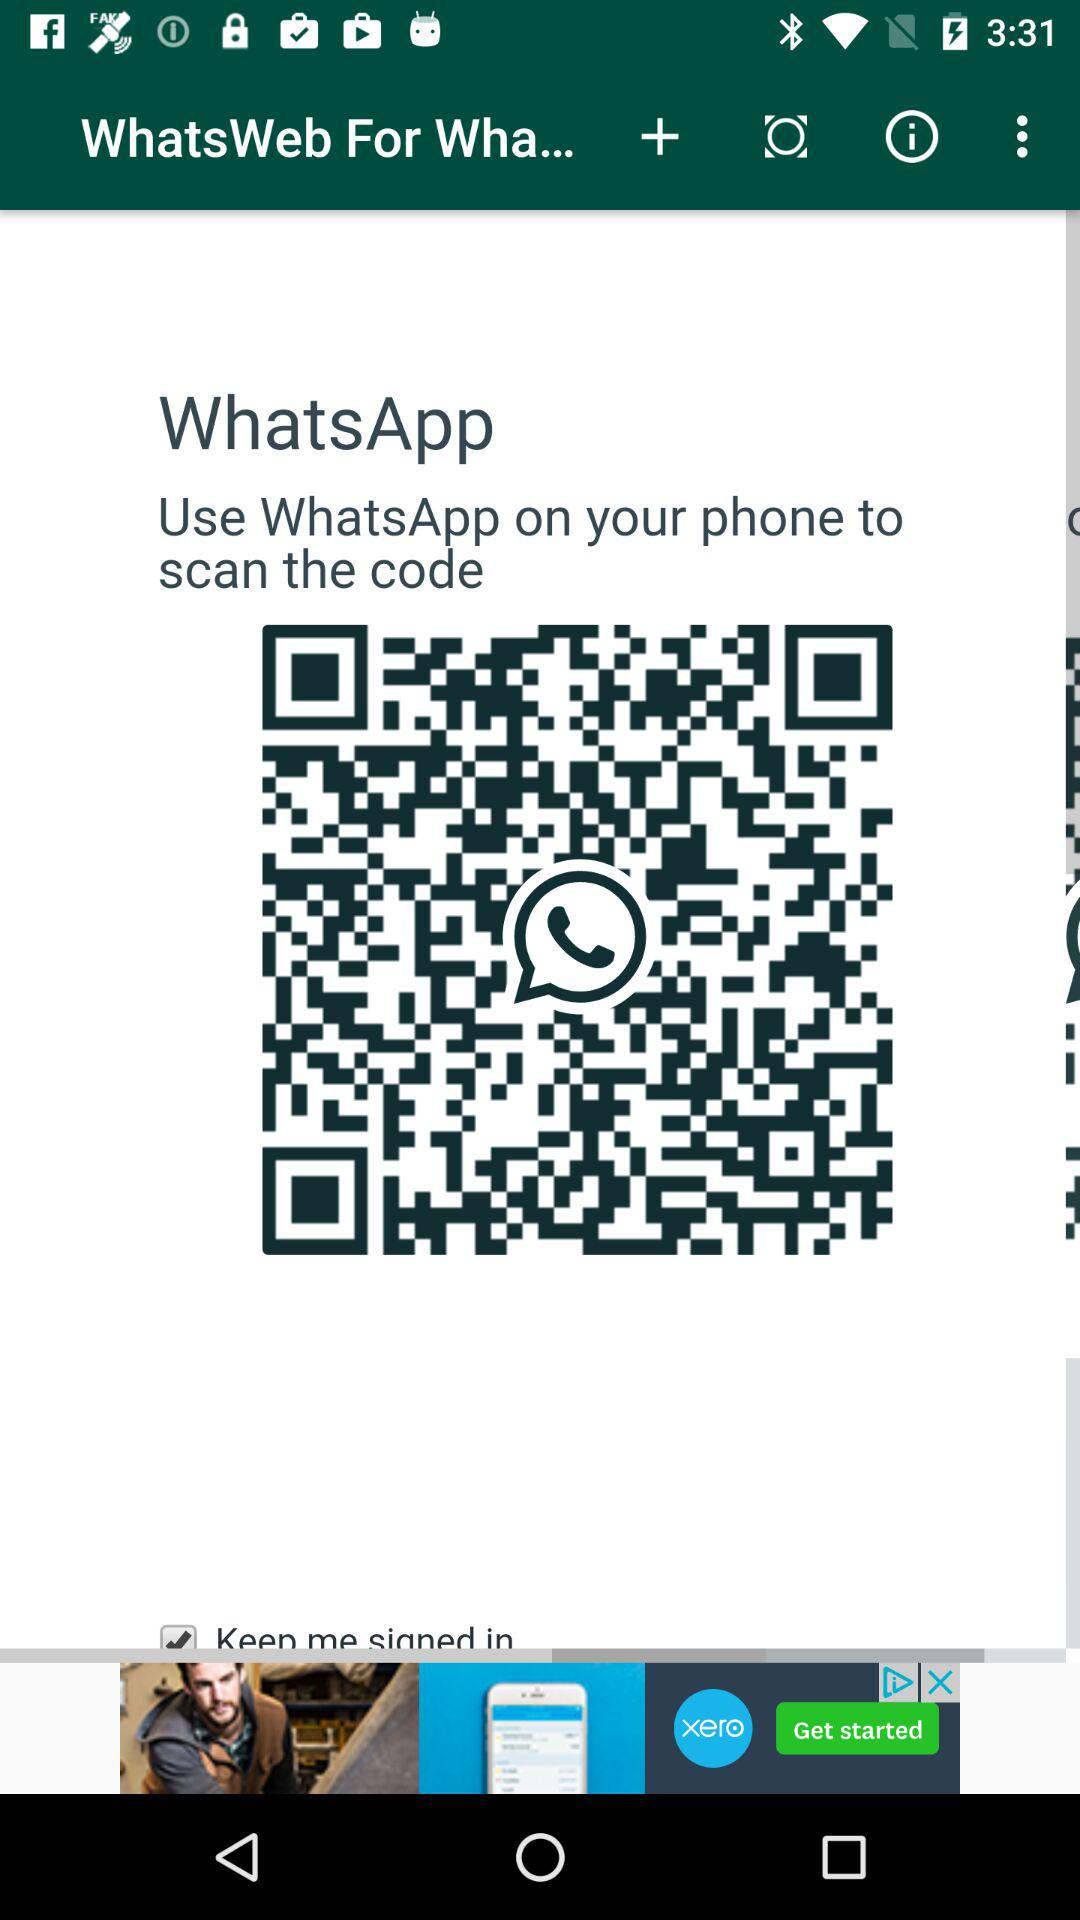What is the name of the application? The names of the applications are "WhatsWeb" and "WhatsApp". 